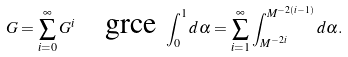Convert formula to latex. <formula><loc_0><loc_0><loc_500><loc_500>G = \sum _ { i = 0 } ^ { \infty } G ^ { i } \quad \text {grce } \int _ { 0 } ^ { 1 } d \alpha = \sum _ { i = 1 } ^ { \infty } \int _ { M ^ { - 2 i } } ^ { M ^ { - 2 ( i - 1 ) } } d \alpha .</formula> 